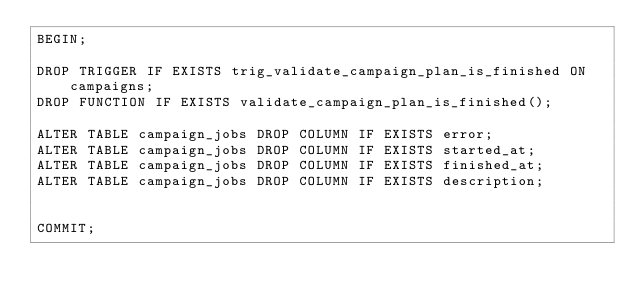<code> <loc_0><loc_0><loc_500><loc_500><_SQL_>BEGIN;

DROP TRIGGER IF EXISTS trig_validate_campaign_plan_is_finished ON campaigns;
DROP FUNCTION IF EXISTS validate_campaign_plan_is_finished();

ALTER TABLE campaign_jobs DROP COLUMN IF EXISTS error;
ALTER TABLE campaign_jobs DROP COLUMN IF EXISTS started_at;
ALTER TABLE campaign_jobs DROP COLUMN IF EXISTS finished_at;
ALTER TABLE campaign_jobs DROP COLUMN IF EXISTS description;


COMMIT;
</code> 